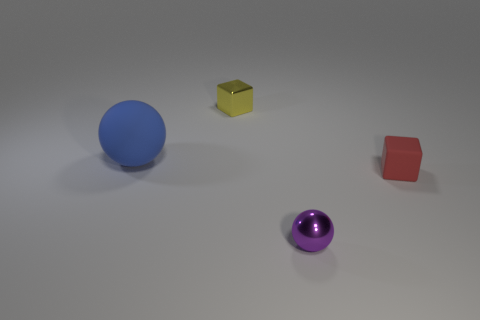Subtract all brown blocks. How many blue balls are left? 1 Add 1 tiny metal balls. How many objects exist? 5 Subtract all blue spheres. How many spheres are left? 1 Subtract 1 cubes. How many cubes are left? 1 Add 2 big spheres. How many big spheres are left? 3 Add 3 large gray shiny cubes. How many large gray shiny cubes exist? 3 Subtract 0 green spheres. How many objects are left? 4 Subtract all cyan spheres. Subtract all purple cylinders. How many spheres are left? 2 Subtract all tiny yellow matte cylinders. Subtract all rubber objects. How many objects are left? 2 